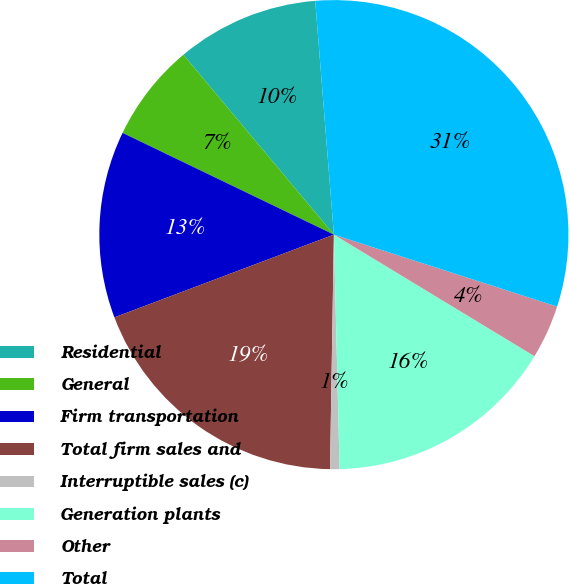<chart> <loc_0><loc_0><loc_500><loc_500><pie_chart><fcel>Residential<fcel>General<fcel>Firm transportation<fcel>Total firm sales and<fcel>Interruptible sales (c)<fcel>Generation plants<fcel>Other<fcel>Total<nl><fcel>9.82%<fcel>6.77%<fcel>12.88%<fcel>19.0%<fcel>0.65%<fcel>15.94%<fcel>3.71%<fcel>31.23%<nl></chart> 